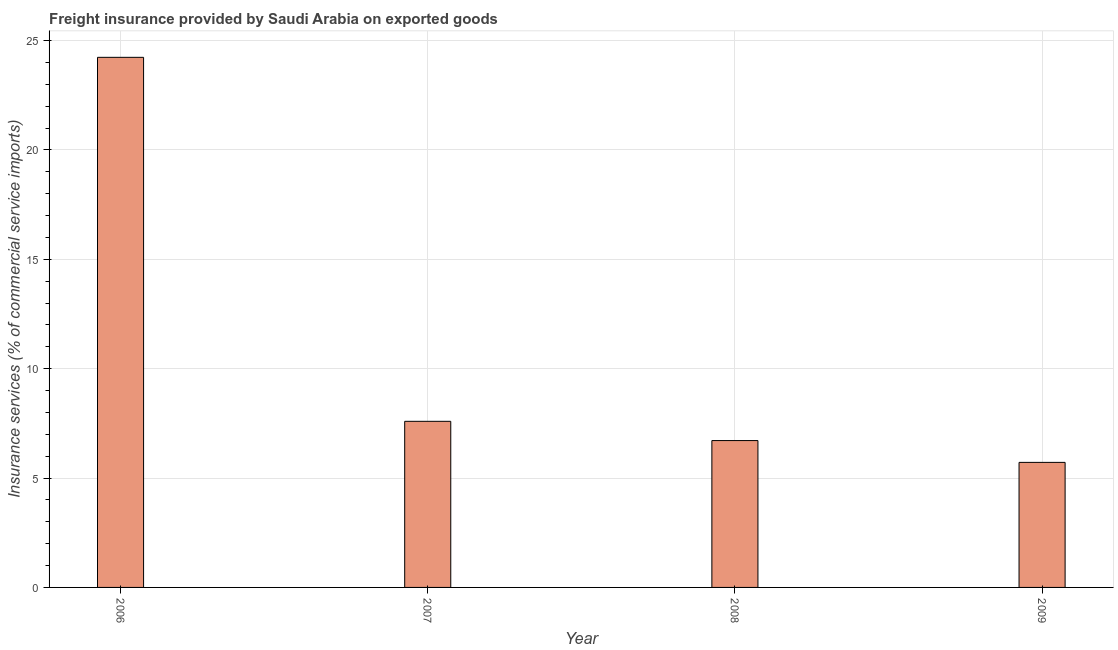What is the title of the graph?
Offer a very short reply. Freight insurance provided by Saudi Arabia on exported goods . What is the label or title of the Y-axis?
Offer a terse response. Insurance services (% of commercial service imports). What is the freight insurance in 2006?
Offer a very short reply. 24.23. Across all years, what is the maximum freight insurance?
Offer a terse response. 24.23. Across all years, what is the minimum freight insurance?
Your response must be concise. 5.72. In which year was the freight insurance maximum?
Offer a terse response. 2006. In which year was the freight insurance minimum?
Give a very brief answer. 2009. What is the sum of the freight insurance?
Keep it short and to the point. 44.26. What is the difference between the freight insurance in 2006 and 2009?
Offer a very short reply. 18.52. What is the average freight insurance per year?
Offer a very short reply. 11.06. What is the median freight insurance?
Keep it short and to the point. 7.15. Do a majority of the years between 2009 and 2007 (inclusive) have freight insurance greater than 15 %?
Your answer should be compact. Yes. What is the ratio of the freight insurance in 2006 to that in 2007?
Offer a terse response. 3.19. Is the freight insurance in 2008 less than that in 2009?
Offer a terse response. No. What is the difference between the highest and the second highest freight insurance?
Ensure brevity in your answer.  16.64. Is the sum of the freight insurance in 2006 and 2008 greater than the maximum freight insurance across all years?
Keep it short and to the point. Yes. What is the difference between the highest and the lowest freight insurance?
Ensure brevity in your answer.  18.52. In how many years, is the freight insurance greater than the average freight insurance taken over all years?
Your answer should be compact. 1. How many bars are there?
Provide a short and direct response. 4. Are all the bars in the graph horizontal?
Your answer should be very brief. No. How many years are there in the graph?
Give a very brief answer. 4. What is the Insurance services (% of commercial service imports) of 2006?
Give a very brief answer. 24.23. What is the Insurance services (% of commercial service imports) of 2007?
Your response must be concise. 7.59. What is the Insurance services (% of commercial service imports) of 2008?
Provide a succinct answer. 6.71. What is the Insurance services (% of commercial service imports) in 2009?
Provide a short and direct response. 5.72. What is the difference between the Insurance services (% of commercial service imports) in 2006 and 2007?
Your response must be concise. 16.64. What is the difference between the Insurance services (% of commercial service imports) in 2006 and 2008?
Offer a terse response. 17.52. What is the difference between the Insurance services (% of commercial service imports) in 2006 and 2009?
Ensure brevity in your answer.  18.52. What is the difference between the Insurance services (% of commercial service imports) in 2007 and 2008?
Offer a terse response. 0.88. What is the difference between the Insurance services (% of commercial service imports) in 2007 and 2009?
Offer a terse response. 1.88. What is the difference between the Insurance services (% of commercial service imports) in 2008 and 2009?
Ensure brevity in your answer.  1. What is the ratio of the Insurance services (% of commercial service imports) in 2006 to that in 2007?
Ensure brevity in your answer.  3.19. What is the ratio of the Insurance services (% of commercial service imports) in 2006 to that in 2008?
Your answer should be very brief. 3.61. What is the ratio of the Insurance services (% of commercial service imports) in 2006 to that in 2009?
Make the answer very short. 4.24. What is the ratio of the Insurance services (% of commercial service imports) in 2007 to that in 2008?
Your answer should be very brief. 1.13. What is the ratio of the Insurance services (% of commercial service imports) in 2007 to that in 2009?
Provide a succinct answer. 1.33. What is the ratio of the Insurance services (% of commercial service imports) in 2008 to that in 2009?
Provide a succinct answer. 1.17. 